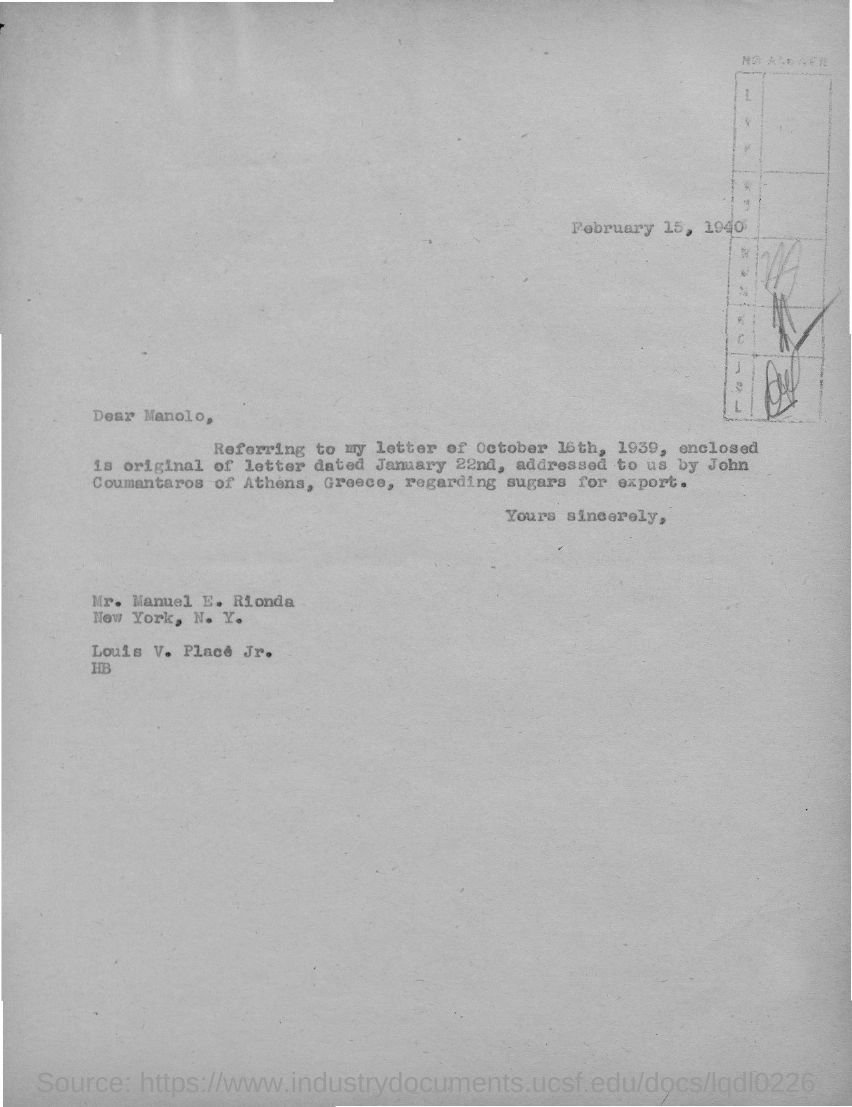When is the letter dated?
Ensure brevity in your answer.  February 15, 1940. To whom the letter is addressed?
Offer a terse response. Manolo. 